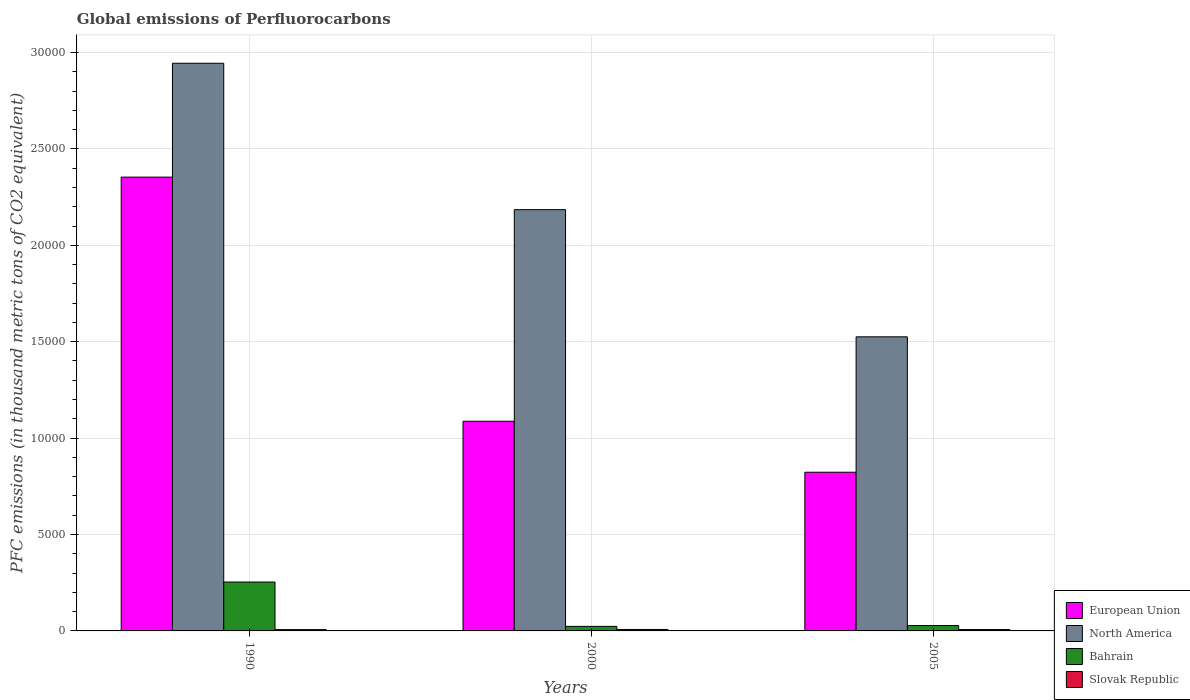How many groups of bars are there?
Offer a terse response. 3. Are the number of bars on each tick of the X-axis equal?
Make the answer very short. Yes. How many bars are there on the 1st tick from the left?
Offer a very short reply. 4. What is the global emissions of Perfluorocarbons in European Union in 2000?
Provide a short and direct response. 1.09e+04. Across all years, what is the maximum global emissions of Perfluorocarbons in Slovak Republic?
Give a very brief answer. 76.3. Across all years, what is the minimum global emissions of Perfluorocarbons in Slovak Republic?
Offer a very short reply. 68.3. In which year was the global emissions of Perfluorocarbons in Bahrain maximum?
Make the answer very short. 1990. In which year was the global emissions of Perfluorocarbons in Bahrain minimum?
Give a very brief answer. 2000. What is the total global emissions of Perfluorocarbons in North America in the graph?
Your answer should be very brief. 6.65e+04. What is the difference between the global emissions of Perfluorocarbons in European Union in 1990 and that in 2005?
Offer a very short reply. 1.53e+04. What is the difference between the global emissions of Perfluorocarbons in Slovak Republic in 2000 and the global emissions of Perfluorocarbons in European Union in 1990?
Give a very brief answer. -2.35e+04. What is the average global emissions of Perfluorocarbons in European Union per year?
Ensure brevity in your answer.  1.42e+04. In the year 2005, what is the difference between the global emissions of Perfluorocarbons in North America and global emissions of Perfluorocarbons in Slovak Republic?
Your answer should be very brief. 1.52e+04. In how many years, is the global emissions of Perfluorocarbons in Bahrain greater than 20000 thousand metric tons?
Provide a succinct answer. 0. What is the ratio of the global emissions of Perfluorocarbons in European Union in 2000 to that in 2005?
Your response must be concise. 1.32. Is the global emissions of Perfluorocarbons in North America in 1990 less than that in 2005?
Offer a terse response. No. Is the difference between the global emissions of Perfluorocarbons in North America in 1990 and 2000 greater than the difference between the global emissions of Perfluorocarbons in Slovak Republic in 1990 and 2000?
Give a very brief answer. Yes. What is the difference between the highest and the second highest global emissions of Perfluorocarbons in North America?
Give a very brief answer. 7592.7. What is the difference between the highest and the lowest global emissions of Perfluorocarbons in Bahrain?
Your answer should be very brief. 2299.6. What does the 4th bar from the left in 2000 represents?
Ensure brevity in your answer.  Slovak Republic. What does the 4th bar from the right in 2005 represents?
Offer a terse response. European Union. Is it the case that in every year, the sum of the global emissions of Perfluorocarbons in European Union and global emissions of Perfluorocarbons in Slovak Republic is greater than the global emissions of Perfluorocarbons in Bahrain?
Offer a terse response. Yes. What is the difference between two consecutive major ticks on the Y-axis?
Ensure brevity in your answer.  5000. Does the graph contain grids?
Keep it short and to the point. Yes. How many legend labels are there?
Provide a succinct answer. 4. What is the title of the graph?
Make the answer very short. Global emissions of Perfluorocarbons. What is the label or title of the Y-axis?
Keep it short and to the point. PFC emissions (in thousand metric tons of CO2 equivalent). What is the PFC emissions (in thousand metric tons of CO2 equivalent) in European Union in 1990?
Your answer should be very brief. 2.35e+04. What is the PFC emissions (in thousand metric tons of CO2 equivalent) of North America in 1990?
Offer a terse response. 2.94e+04. What is the PFC emissions (in thousand metric tons of CO2 equivalent) of Bahrain in 1990?
Your response must be concise. 2535.7. What is the PFC emissions (in thousand metric tons of CO2 equivalent) of Slovak Republic in 1990?
Your answer should be compact. 68.3. What is the PFC emissions (in thousand metric tons of CO2 equivalent) in European Union in 2000?
Offer a terse response. 1.09e+04. What is the PFC emissions (in thousand metric tons of CO2 equivalent) in North America in 2000?
Your response must be concise. 2.18e+04. What is the PFC emissions (in thousand metric tons of CO2 equivalent) of Bahrain in 2000?
Provide a succinct answer. 236.1. What is the PFC emissions (in thousand metric tons of CO2 equivalent) of Slovak Republic in 2000?
Give a very brief answer. 76.3. What is the PFC emissions (in thousand metric tons of CO2 equivalent) of European Union in 2005?
Your response must be concise. 8230.79. What is the PFC emissions (in thousand metric tons of CO2 equivalent) of North America in 2005?
Give a very brief answer. 1.53e+04. What is the PFC emissions (in thousand metric tons of CO2 equivalent) of Bahrain in 2005?
Offer a terse response. 278.6. What is the PFC emissions (in thousand metric tons of CO2 equivalent) in Slovak Republic in 2005?
Your response must be concise. 71.6. Across all years, what is the maximum PFC emissions (in thousand metric tons of CO2 equivalent) in European Union?
Your response must be concise. 2.35e+04. Across all years, what is the maximum PFC emissions (in thousand metric tons of CO2 equivalent) in North America?
Your answer should be compact. 2.94e+04. Across all years, what is the maximum PFC emissions (in thousand metric tons of CO2 equivalent) of Bahrain?
Offer a terse response. 2535.7. Across all years, what is the maximum PFC emissions (in thousand metric tons of CO2 equivalent) of Slovak Republic?
Offer a very short reply. 76.3. Across all years, what is the minimum PFC emissions (in thousand metric tons of CO2 equivalent) of European Union?
Provide a succinct answer. 8230.79. Across all years, what is the minimum PFC emissions (in thousand metric tons of CO2 equivalent) in North America?
Provide a succinct answer. 1.53e+04. Across all years, what is the minimum PFC emissions (in thousand metric tons of CO2 equivalent) in Bahrain?
Provide a succinct answer. 236.1. Across all years, what is the minimum PFC emissions (in thousand metric tons of CO2 equivalent) of Slovak Republic?
Keep it short and to the point. 68.3. What is the total PFC emissions (in thousand metric tons of CO2 equivalent) in European Union in the graph?
Your answer should be very brief. 4.26e+04. What is the total PFC emissions (in thousand metric tons of CO2 equivalent) of North America in the graph?
Keep it short and to the point. 6.65e+04. What is the total PFC emissions (in thousand metric tons of CO2 equivalent) of Bahrain in the graph?
Provide a short and direct response. 3050.4. What is the total PFC emissions (in thousand metric tons of CO2 equivalent) in Slovak Republic in the graph?
Keep it short and to the point. 216.2. What is the difference between the PFC emissions (in thousand metric tons of CO2 equivalent) of European Union in 1990 and that in 2000?
Your response must be concise. 1.27e+04. What is the difference between the PFC emissions (in thousand metric tons of CO2 equivalent) of North America in 1990 and that in 2000?
Your answer should be very brief. 7592.7. What is the difference between the PFC emissions (in thousand metric tons of CO2 equivalent) of Bahrain in 1990 and that in 2000?
Ensure brevity in your answer.  2299.6. What is the difference between the PFC emissions (in thousand metric tons of CO2 equivalent) of Slovak Republic in 1990 and that in 2000?
Keep it short and to the point. -8. What is the difference between the PFC emissions (in thousand metric tons of CO2 equivalent) in European Union in 1990 and that in 2005?
Provide a short and direct response. 1.53e+04. What is the difference between the PFC emissions (in thousand metric tons of CO2 equivalent) of North America in 1990 and that in 2005?
Your answer should be compact. 1.42e+04. What is the difference between the PFC emissions (in thousand metric tons of CO2 equivalent) in Bahrain in 1990 and that in 2005?
Keep it short and to the point. 2257.1. What is the difference between the PFC emissions (in thousand metric tons of CO2 equivalent) in Slovak Republic in 1990 and that in 2005?
Your answer should be compact. -3.3. What is the difference between the PFC emissions (in thousand metric tons of CO2 equivalent) of European Union in 2000 and that in 2005?
Your answer should be compact. 2643.81. What is the difference between the PFC emissions (in thousand metric tons of CO2 equivalent) in North America in 2000 and that in 2005?
Provide a short and direct response. 6595.81. What is the difference between the PFC emissions (in thousand metric tons of CO2 equivalent) of Bahrain in 2000 and that in 2005?
Provide a succinct answer. -42.5. What is the difference between the PFC emissions (in thousand metric tons of CO2 equivalent) in European Union in 1990 and the PFC emissions (in thousand metric tons of CO2 equivalent) in North America in 2000?
Offer a very short reply. 1687.6. What is the difference between the PFC emissions (in thousand metric tons of CO2 equivalent) of European Union in 1990 and the PFC emissions (in thousand metric tons of CO2 equivalent) of Bahrain in 2000?
Offer a very short reply. 2.33e+04. What is the difference between the PFC emissions (in thousand metric tons of CO2 equivalent) of European Union in 1990 and the PFC emissions (in thousand metric tons of CO2 equivalent) of Slovak Republic in 2000?
Provide a succinct answer. 2.35e+04. What is the difference between the PFC emissions (in thousand metric tons of CO2 equivalent) of North America in 1990 and the PFC emissions (in thousand metric tons of CO2 equivalent) of Bahrain in 2000?
Provide a short and direct response. 2.92e+04. What is the difference between the PFC emissions (in thousand metric tons of CO2 equivalent) of North America in 1990 and the PFC emissions (in thousand metric tons of CO2 equivalent) of Slovak Republic in 2000?
Make the answer very short. 2.94e+04. What is the difference between the PFC emissions (in thousand metric tons of CO2 equivalent) of Bahrain in 1990 and the PFC emissions (in thousand metric tons of CO2 equivalent) of Slovak Republic in 2000?
Offer a very short reply. 2459.4. What is the difference between the PFC emissions (in thousand metric tons of CO2 equivalent) of European Union in 1990 and the PFC emissions (in thousand metric tons of CO2 equivalent) of North America in 2005?
Ensure brevity in your answer.  8283.41. What is the difference between the PFC emissions (in thousand metric tons of CO2 equivalent) in European Union in 1990 and the PFC emissions (in thousand metric tons of CO2 equivalent) in Bahrain in 2005?
Provide a succinct answer. 2.33e+04. What is the difference between the PFC emissions (in thousand metric tons of CO2 equivalent) in European Union in 1990 and the PFC emissions (in thousand metric tons of CO2 equivalent) in Slovak Republic in 2005?
Your answer should be very brief. 2.35e+04. What is the difference between the PFC emissions (in thousand metric tons of CO2 equivalent) in North America in 1990 and the PFC emissions (in thousand metric tons of CO2 equivalent) in Bahrain in 2005?
Your response must be concise. 2.92e+04. What is the difference between the PFC emissions (in thousand metric tons of CO2 equivalent) of North America in 1990 and the PFC emissions (in thousand metric tons of CO2 equivalent) of Slovak Republic in 2005?
Provide a succinct answer. 2.94e+04. What is the difference between the PFC emissions (in thousand metric tons of CO2 equivalent) of Bahrain in 1990 and the PFC emissions (in thousand metric tons of CO2 equivalent) of Slovak Republic in 2005?
Offer a very short reply. 2464.1. What is the difference between the PFC emissions (in thousand metric tons of CO2 equivalent) of European Union in 2000 and the PFC emissions (in thousand metric tons of CO2 equivalent) of North America in 2005?
Offer a very short reply. -4378.49. What is the difference between the PFC emissions (in thousand metric tons of CO2 equivalent) in European Union in 2000 and the PFC emissions (in thousand metric tons of CO2 equivalent) in Bahrain in 2005?
Provide a succinct answer. 1.06e+04. What is the difference between the PFC emissions (in thousand metric tons of CO2 equivalent) of European Union in 2000 and the PFC emissions (in thousand metric tons of CO2 equivalent) of Slovak Republic in 2005?
Ensure brevity in your answer.  1.08e+04. What is the difference between the PFC emissions (in thousand metric tons of CO2 equivalent) in North America in 2000 and the PFC emissions (in thousand metric tons of CO2 equivalent) in Bahrain in 2005?
Provide a succinct answer. 2.16e+04. What is the difference between the PFC emissions (in thousand metric tons of CO2 equivalent) in North America in 2000 and the PFC emissions (in thousand metric tons of CO2 equivalent) in Slovak Republic in 2005?
Keep it short and to the point. 2.18e+04. What is the difference between the PFC emissions (in thousand metric tons of CO2 equivalent) of Bahrain in 2000 and the PFC emissions (in thousand metric tons of CO2 equivalent) of Slovak Republic in 2005?
Your answer should be compact. 164.5. What is the average PFC emissions (in thousand metric tons of CO2 equivalent) of European Union per year?
Keep it short and to the point. 1.42e+04. What is the average PFC emissions (in thousand metric tons of CO2 equivalent) of North America per year?
Keep it short and to the point. 2.22e+04. What is the average PFC emissions (in thousand metric tons of CO2 equivalent) in Bahrain per year?
Provide a short and direct response. 1016.8. What is the average PFC emissions (in thousand metric tons of CO2 equivalent) of Slovak Republic per year?
Offer a very short reply. 72.07. In the year 1990, what is the difference between the PFC emissions (in thousand metric tons of CO2 equivalent) of European Union and PFC emissions (in thousand metric tons of CO2 equivalent) of North America?
Offer a terse response. -5905.1. In the year 1990, what is the difference between the PFC emissions (in thousand metric tons of CO2 equivalent) in European Union and PFC emissions (in thousand metric tons of CO2 equivalent) in Bahrain?
Make the answer very short. 2.10e+04. In the year 1990, what is the difference between the PFC emissions (in thousand metric tons of CO2 equivalent) in European Union and PFC emissions (in thousand metric tons of CO2 equivalent) in Slovak Republic?
Make the answer very short. 2.35e+04. In the year 1990, what is the difference between the PFC emissions (in thousand metric tons of CO2 equivalent) in North America and PFC emissions (in thousand metric tons of CO2 equivalent) in Bahrain?
Offer a terse response. 2.69e+04. In the year 1990, what is the difference between the PFC emissions (in thousand metric tons of CO2 equivalent) in North America and PFC emissions (in thousand metric tons of CO2 equivalent) in Slovak Republic?
Your response must be concise. 2.94e+04. In the year 1990, what is the difference between the PFC emissions (in thousand metric tons of CO2 equivalent) in Bahrain and PFC emissions (in thousand metric tons of CO2 equivalent) in Slovak Republic?
Make the answer very short. 2467.4. In the year 2000, what is the difference between the PFC emissions (in thousand metric tons of CO2 equivalent) of European Union and PFC emissions (in thousand metric tons of CO2 equivalent) of North America?
Provide a succinct answer. -1.10e+04. In the year 2000, what is the difference between the PFC emissions (in thousand metric tons of CO2 equivalent) of European Union and PFC emissions (in thousand metric tons of CO2 equivalent) of Bahrain?
Keep it short and to the point. 1.06e+04. In the year 2000, what is the difference between the PFC emissions (in thousand metric tons of CO2 equivalent) of European Union and PFC emissions (in thousand metric tons of CO2 equivalent) of Slovak Republic?
Give a very brief answer. 1.08e+04. In the year 2000, what is the difference between the PFC emissions (in thousand metric tons of CO2 equivalent) in North America and PFC emissions (in thousand metric tons of CO2 equivalent) in Bahrain?
Keep it short and to the point. 2.16e+04. In the year 2000, what is the difference between the PFC emissions (in thousand metric tons of CO2 equivalent) in North America and PFC emissions (in thousand metric tons of CO2 equivalent) in Slovak Republic?
Provide a succinct answer. 2.18e+04. In the year 2000, what is the difference between the PFC emissions (in thousand metric tons of CO2 equivalent) in Bahrain and PFC emissions (in thousand metric tons of CO2 equivalent) in Slovak Republic?
Your answer should be very brief. 159.8. In the year 2005, what is the difference between the PFC emissions (in thousand metric tons of CO2 equivalent) of European Union and PFC emissions (in thousand metric tons of CO2 equivalent) of North America?
Offer a very short reply. -7022.3. In the year 2005, what is the difference between the PFC emissions (in thousand metric tons of CO2 equivalent) of European Union and PFC emissions (in thousand metric tons of CO2 equivalent) of Bahrain?
Keep it short and to the point. 7952.19. In the year 2005, what is the difference between the PFC emissions (in thousand metric tons of CO2 equivalent) in European Union and PFC emissions (in thousand metric tons of CO2 equivalent) in Slovak Republic?
Offer a very short reply. 8159.19. In the year 2005, what is the difference between the PFC emissions (in thousand metric tons of CO2 equivalent) of North America and PFC emissions (in thousand metric tons of CO2 equivalent) of Bahrain?
Offer a very short reply. 1.50e+04. In the year 2005, what is the difference between the PFC emissions (in thousand metric tons of CO2 equivalent) of North America and PFC emissions (in thousand metric tons of CO2 equivalent) of Slovak Republic?
Ensure brevity in your answer.  1.52e+04. In the year 2005, what is the difference between the PFC emissions (in thousand metric tons of CO2 equivalent) in Bahrain and PFC emissions (in thousand metric tons of CO2 equivalent) in Slovak Republic?
Your answer should be compact. 207. What is the ratio of the PFC emissions (in thousand metric tons of CO2 equivalent) in European Union in 1990 to that in 2000?
Give a very brief answer. 2.16. What is the ratio of the PFC emissions (in thousand metric tons of CO2 equivalent) of North America in 1990 to that in 2000?
Your response must be concise. 1.35. What is the ratio of the PFC emissions (in thousand metric tons of CO2 equivalent) in Bahrain in 1990 to that in 2000?
Ensure brevity in your answer.  10.74. What is the ratio of the PFC emissions (in thousand metric tons of CO2 equivalent) of Slovak Republic in 1990 to that in 2000?
Make the answer very short. 0.9. What is the ratio of the PFC emissions (in thousand metric tons of CO2 equivalent) of European Union in 1990 to that in 2005?
Give a very brief answer. 2.86. What is the ratio of the PFC emissions (in thousand metric tons of CO2 equivalent) in North America in 1990 to that in 2005?
Your answer should be compact. 1.93. What is the ratio of the PFC emissions (in thousand metric tons of CO2 equivalent) in Bahrain in 1990 to that in 2005?
Offer a very short reply. 9.1. What is the ratio of the PFC emissions (in thousand metric tons of CO2 equivalent) in Slovak Republic in 1990 to that in 2005?
Give a very brief answer. 0.95. What is the ratio of the PFC emissions (in thousand metric tons of CO2 equivalent) of European Union in 2000 to that in 2005?
Your response must be concise. 1.32. What is the ratio of the PFC emissions (in thousand metric tons of CO2 equivalent) in North America in 2000 to that in 2005?
Provide a short and direct response. 1.43. What is the ratio of the PFC emissions (in thousand metric tons of CO2 equivalent) in Bahrain in 2000 to that in 2005?
Give a very brief answer. 0.85. What is the ratio of the PFC emissions (in thousand metric tons of CO2 equivalent) of Slovak Republic in 2000 to that in 2005?
Your answer should be compact. 1.07. What is the difference between the highest and the second highest PFC emissions (in thousand metric tons of CO2 equivalent) of European Union?
Ensure brevity in your answer.  1.27e+04. What is the difference between the highest and the second highest PFC emissions (in thousand metric tons of CO2 equivalent) in North America?
Your response must be concise. 7592.7. What is the difference between the highest and the second highest PFC emissions (in thousand metric tons of CO2 equivalent) of Bahrain?
Keep it short and to the point. 2257.1. What is the difference between the highest and the lowest PFC emissions (in thousand metric tons of CO2 equivalent) in European Union?
Your answer should be very brief. 1.53e+04. What is the difference between the highest and the lowest PFC emissions (in thousand metric tons of CO2 equivalent) in North America?
Your answer should be very brief. 1.42e+04. What is the difference between the highest and the lowest PFC emissions (in thousand metric tons of CO2 equivalent) of Bahrain?
Your answer should be very brief. 2299.6. 